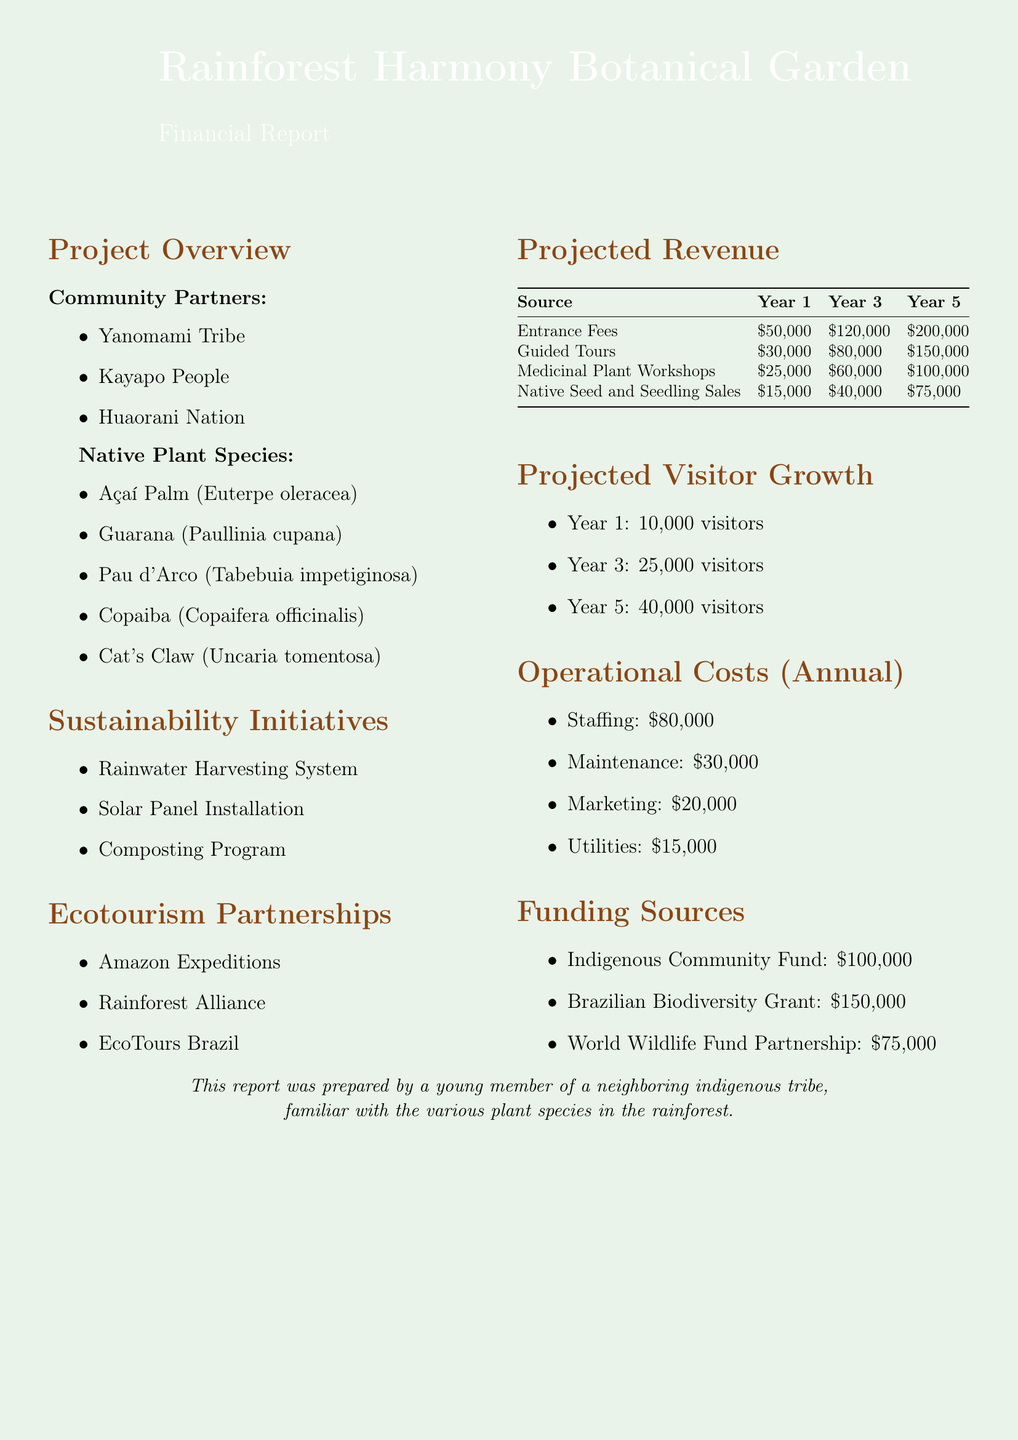What is the project title? The project title is mentioned at the beginning of the document, which is "Rainforest Harmony Botanical Garden."
Answer: Rainforest Harmony Botanical Garden Who are the community partners? The community partners listed include the indigenous tribes involved in the project: Yanomami Tribe, Kayapo People, and Huaorani Nation.
Answer: Yanomami Tribe, Kayapo People, Huaorani Nation What are the operational costs for staffing? The operational costs provided detail the expenses, and staffing costs are specified as $80,000.
Answer: $80,000 What is the projected revenue from Guided Tours in year three? The projected revenue for Guided Tours in year three is directly stated in the revenue section of the document.
Answer: $80,000 How many visitors are projected in year five? The document lists the expected number of visitors for year five as part of the projected visitor growth section.
Answer: 40,000 What is the total projected revenue in year one? The total projected revenue is calculated by summing the individual sources of revenue in year one.
Answer: $120,000 What sustainability initiative is mentioned in the document? One of the sustainability initiatives described in the document is the Rainwater Harvesting System.
Answer: Rainwater Harvesting System What is the amount of the Brazilian Biodiversity Grant? The amount provided for the Brazilian Biodiversity Grant is clearly stated in the funding sources section.
Answer: $150,000 Which ecotourism partnership is listed first? The first partnership mentioned under ecotourism partnerships in the list is Amazon Expeditions.
Answer: Amazon Expeditions 